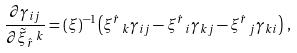Convert formula to latex. <formula><loc_0><loc_0><loc_500><loc_500>\frac { \partial \gamma _ { i j } } { \partial \tilde { \xi } _ { \hat { r } } \, ^ { k } } = ( \xi ) ^ { - 1 } \left ( \xi ^ { \hat { r } } \, _ { k } \gamma _ { i j } - \xi ^ { \hat { r } } \, _ { i } \gamma _ { k j } - \xi ^ { \hat { r } } \, _ { j } \gamma _ { k i } \right ) \, ,</formula> 